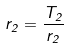Convert formula to latex. <formula><loc_0><loc_0><loc_500><loc_500>r _ { 2 } = \frac { T _ { 2 } } { r _ { 2 } }</formula> 